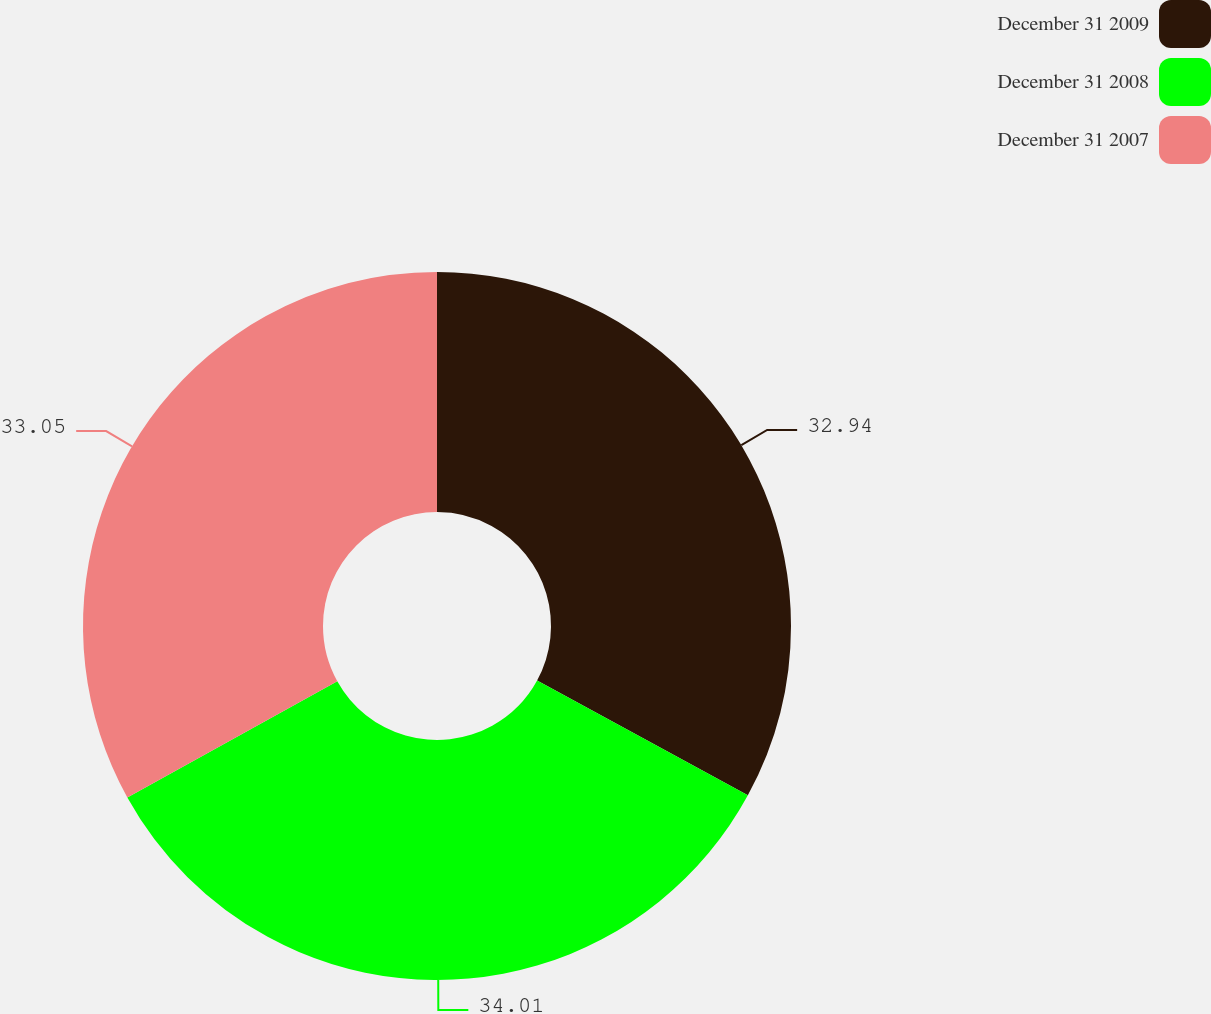Convert chart to OTSL. <chart><loc_0><loc_0><loc_500><loc_500><pie_chart><fcel>December 31 2009<fcel>December 31 2008<fcel>December 31 2007<nl><fcel>32.94%<fcel>34.01%<fcel>33.05%<nl></chart> 